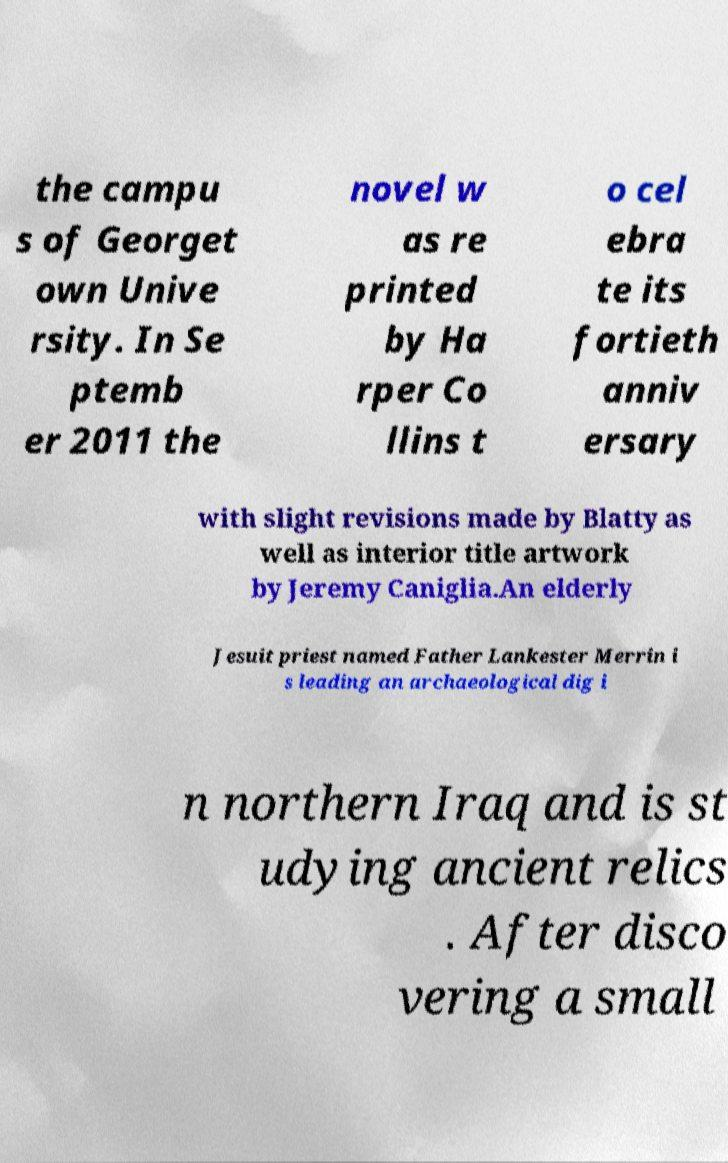What messages or text are displayed in this image? I need them in a readable, typed format. the campu s of Georget own Unive rsity. In Se ptemb er 2011 the novel w as re printed by Ha rper Co llins t o cel ebra te its fortieth anniv ersary with slight revisions made by Blatty as well as interior title artwork by Jeremy Caniglia.An elderly Jesuit priest named Father Lankester Merrin i s leading an archaeological dig i n northern Iraq and is st udying ancient relics . After disco vering a small 